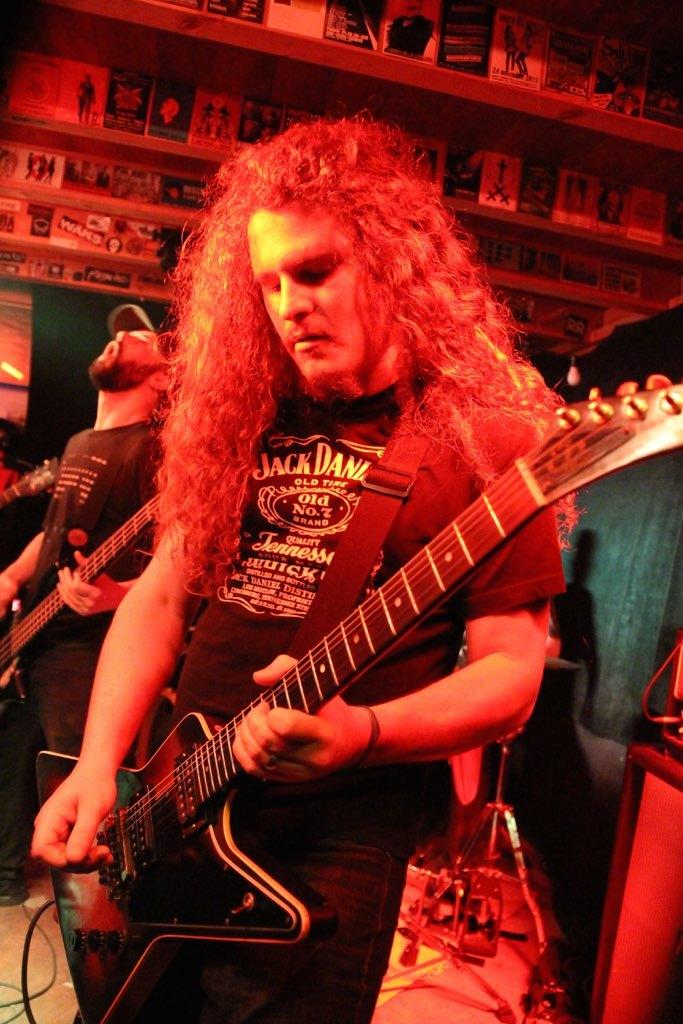What are the men in the image doing? The men in the image are playing a guitar. How are the men positioned in the image? The men are standing. What can be seen in the background of the image? There are posters in the background of the image. What type of bead is being used by the men in the image? There is no mention of a bead in the image, so it cannot be determined if a bead is being used. 